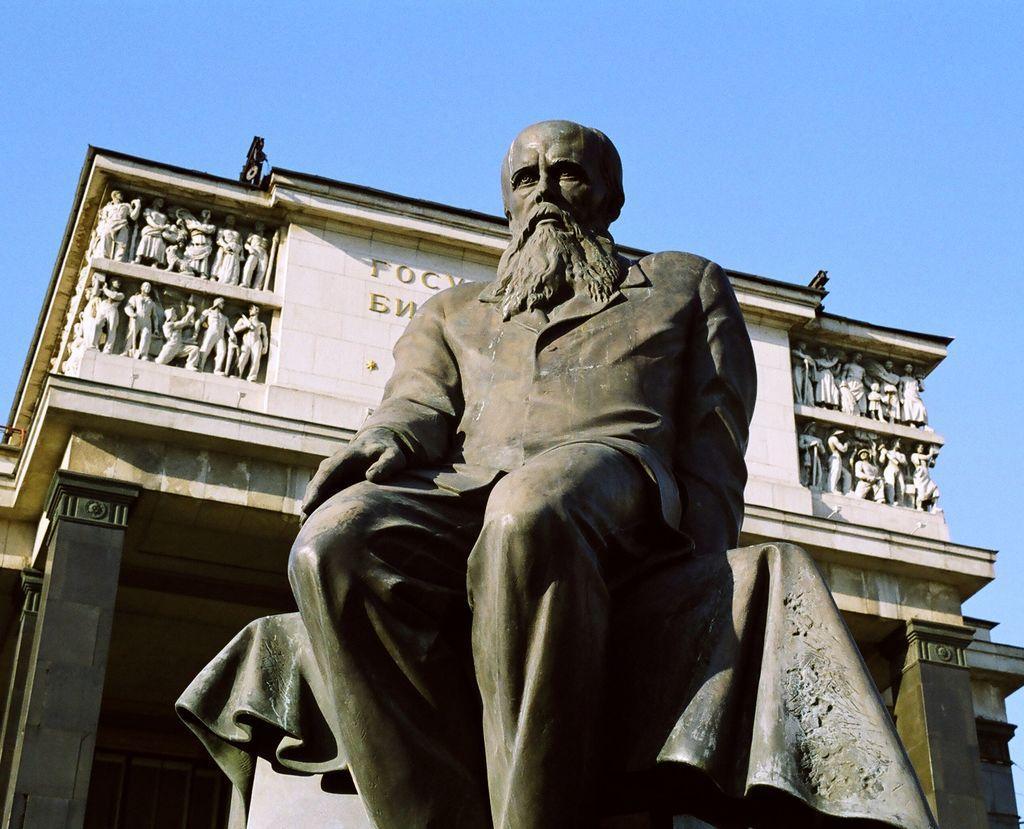Please provide a concise description of this image. In this image we can see a statue, behind the statue we can see a building, on the building there are some statues and text, in the background we can see the sky. 